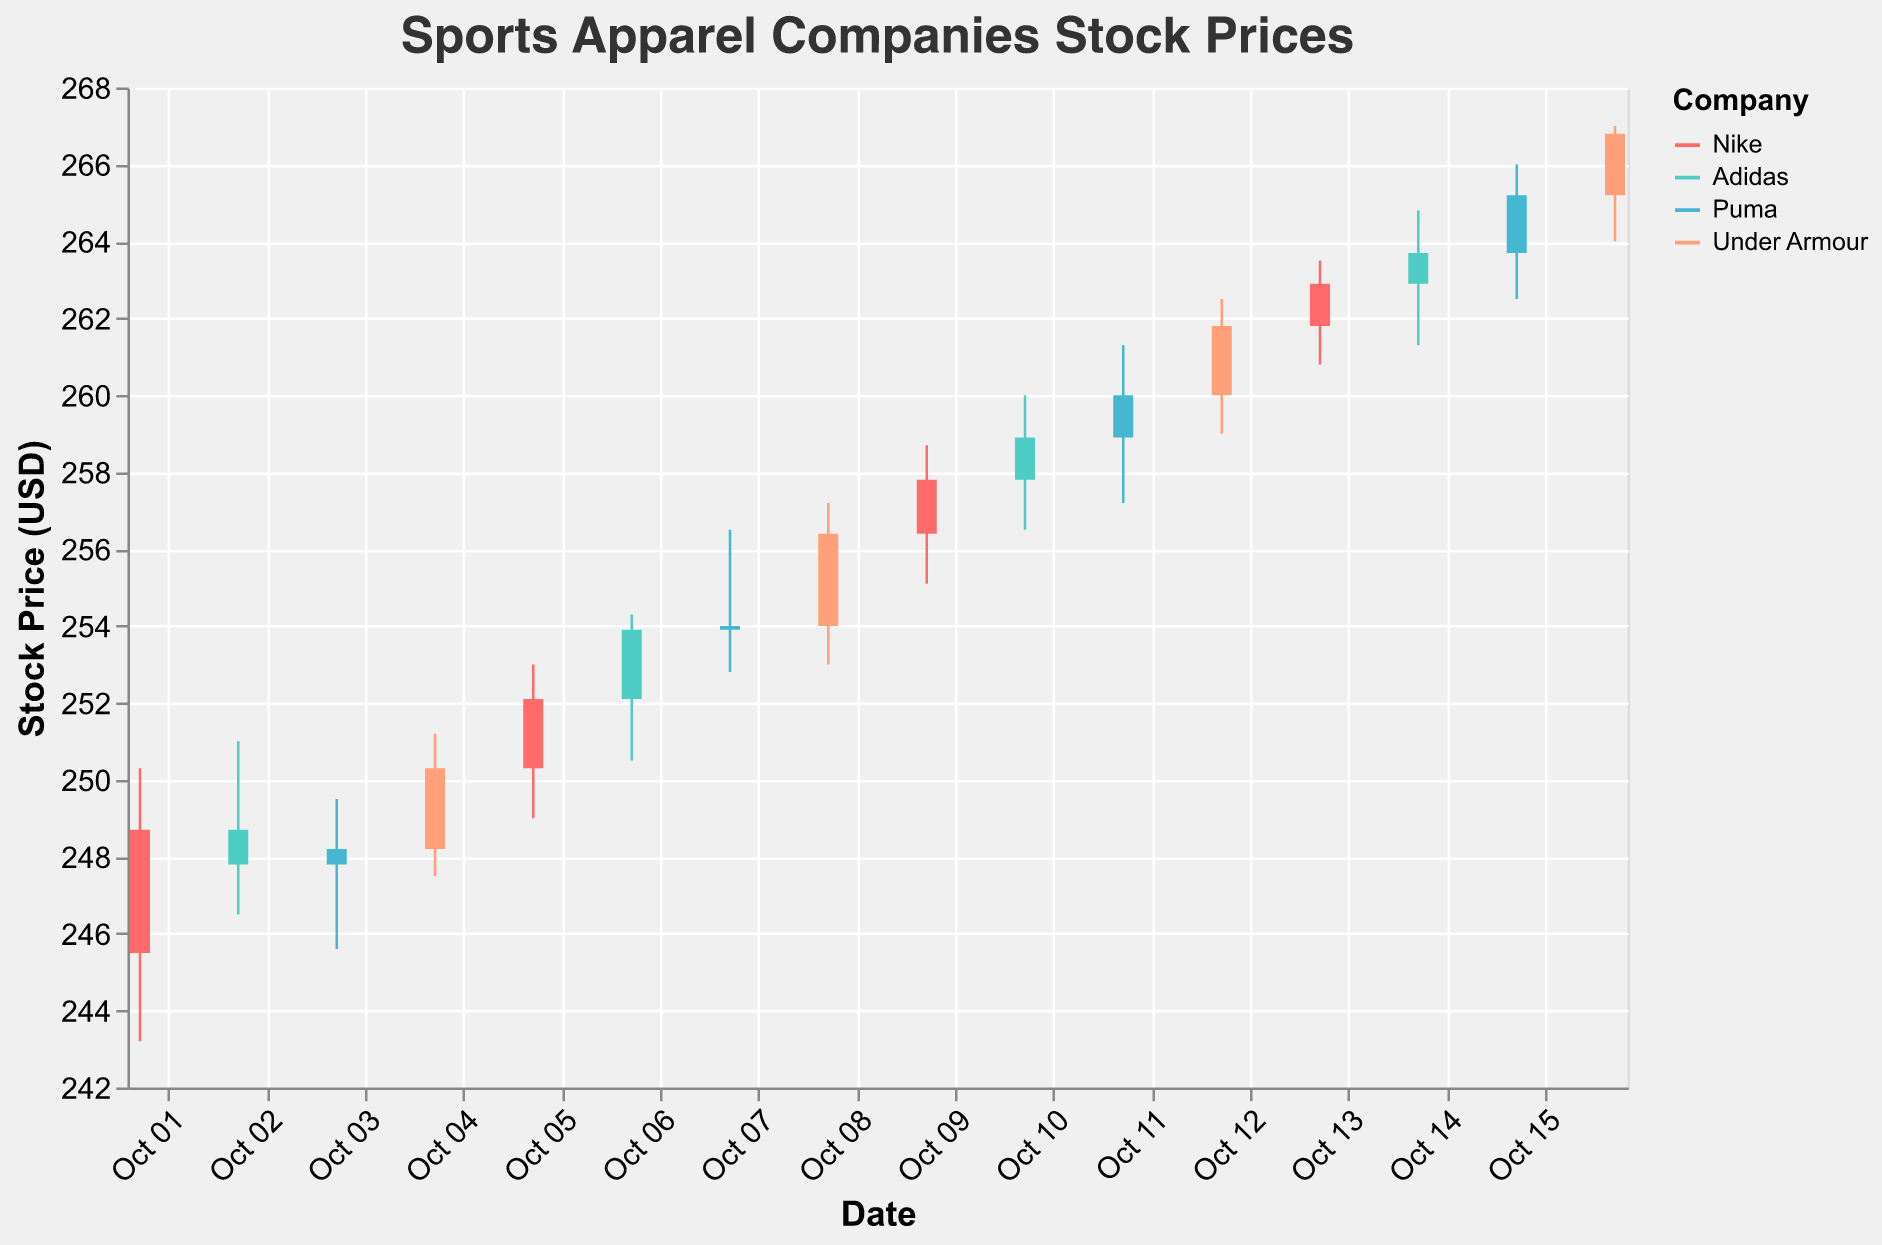Which company had the highest closing price on October 10? To determine the company with the highest closing price on October 10, we can compare the closing prices of the companies listed for that day in the figure. From the data, on October 10: Nike (257.80), Adidas (258.90), Puma (260.00), and Under Armour (261.80). Under Armour has the highest closing price.
Answer: Under Armour Between October 9 and October 11, which company showed the most increase in closing price? First, calculate the closing price differences for each company between October 9 and October 11. For Nike: 262.90 - 257.80 = 5.10. For Adidas: 263.70 - 258.90 = 4.80. For Puma: 265.20 - 260.00 = 5.20. For Under Armour: 266.80 - 261.80 = 5.00. Puma shows the most increase.
Answer: Puma What is the overall trend for Nike's stock prices during the period shown? Review the opening and closing prices for Nike on each date provided: starting at 245.50 on October 1 and closing at 262.90 on October 13. Nike's stock prices generally show an upward trend, indicating a consistent increase over the period.
Answer: Upward trend Which day's trading had the highest volume? To identify the day with the highest trading volume, compare the volumes for each date. From the dataset, October 16 has the highest volume with 4,100,000.
Answer: October 16 What was the lowest trading price for Puma on October 3? Check the low price for Puma on October 3 in the dataset, which lists it as 245.60.
Answer: 245.60 On October 7, did Adidas or Nike have a higher closing price? Adidas's closing price on October 7 is 253.90, while Nike did not trade on this date. Referencing other dates close to October 7 confirms Adidas had a higher closing price that day.
Answer: Adidas How many companies experienced a closing price above 255 USD on October 8? Analyze the closing prices listed for October 8: Nike (257.80), Adidas (258.90), Puma (260.00), and Under Armour (261.80). All four companies experienced closing prices above 255 USD.
Answer: 4 What was the difference in closing price between Adidas and Puma on October 10? To find the difference, subtract the closing price of Adidas from Puma on October 10: 260.00 - 258.90 = 1.10.
Answer: 1.10 Between October 4 and October 8, which company had the highest average closing price? Calculate the average closing price for each company over these days. Nike: (250.30 + 252.10 + 257.80)/3 = 253.40. Adidas: (247.80 + 253.90 + 258.90)/3 = 253.53. Puma: (248.20 + 254.00 + 260.00)/3 = 254.07. Under Armour: (250.30 + 256.40 + 261.80)/3 = 256.83. Under Armour had the highest average.
Answer: Under Armour 